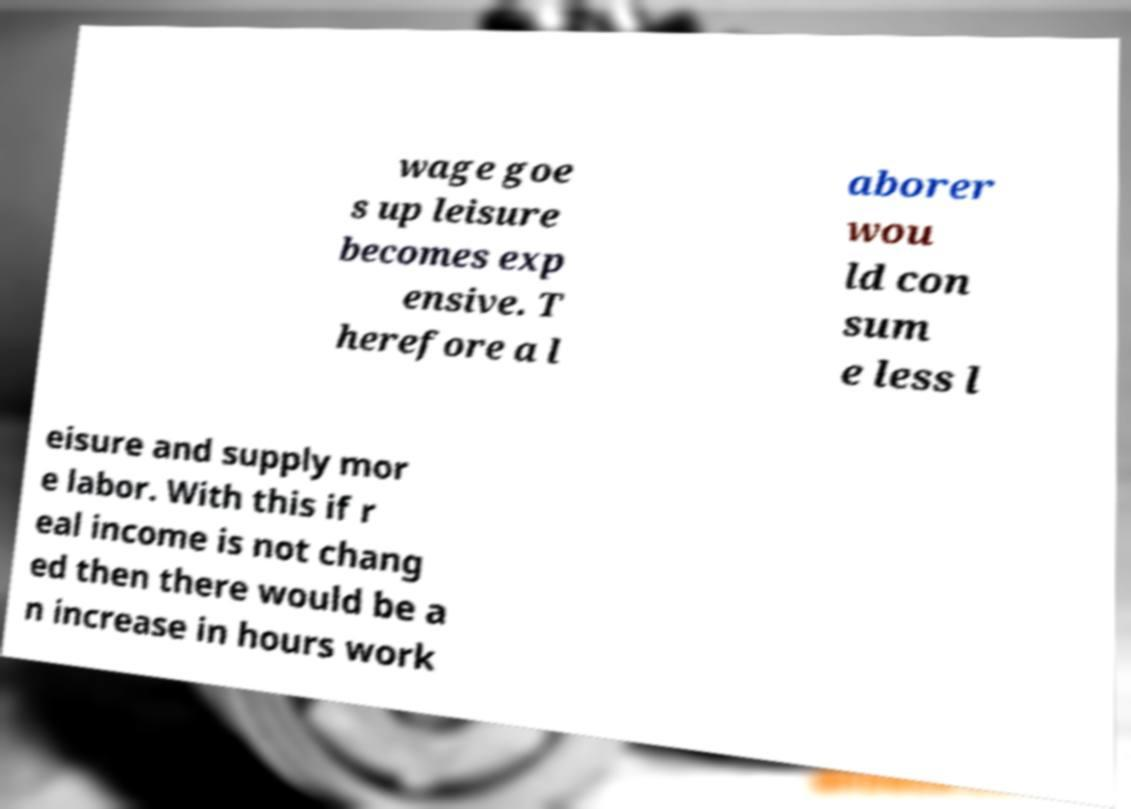Please identify and transcribe the text found in this image. wage goe s up leisure becomes exp ensive. T herefore a l aborer wou ld con sum e less l eisure and supply mor e labor. With this if r eal income is not chang ed then there would be a n increase in hours work 